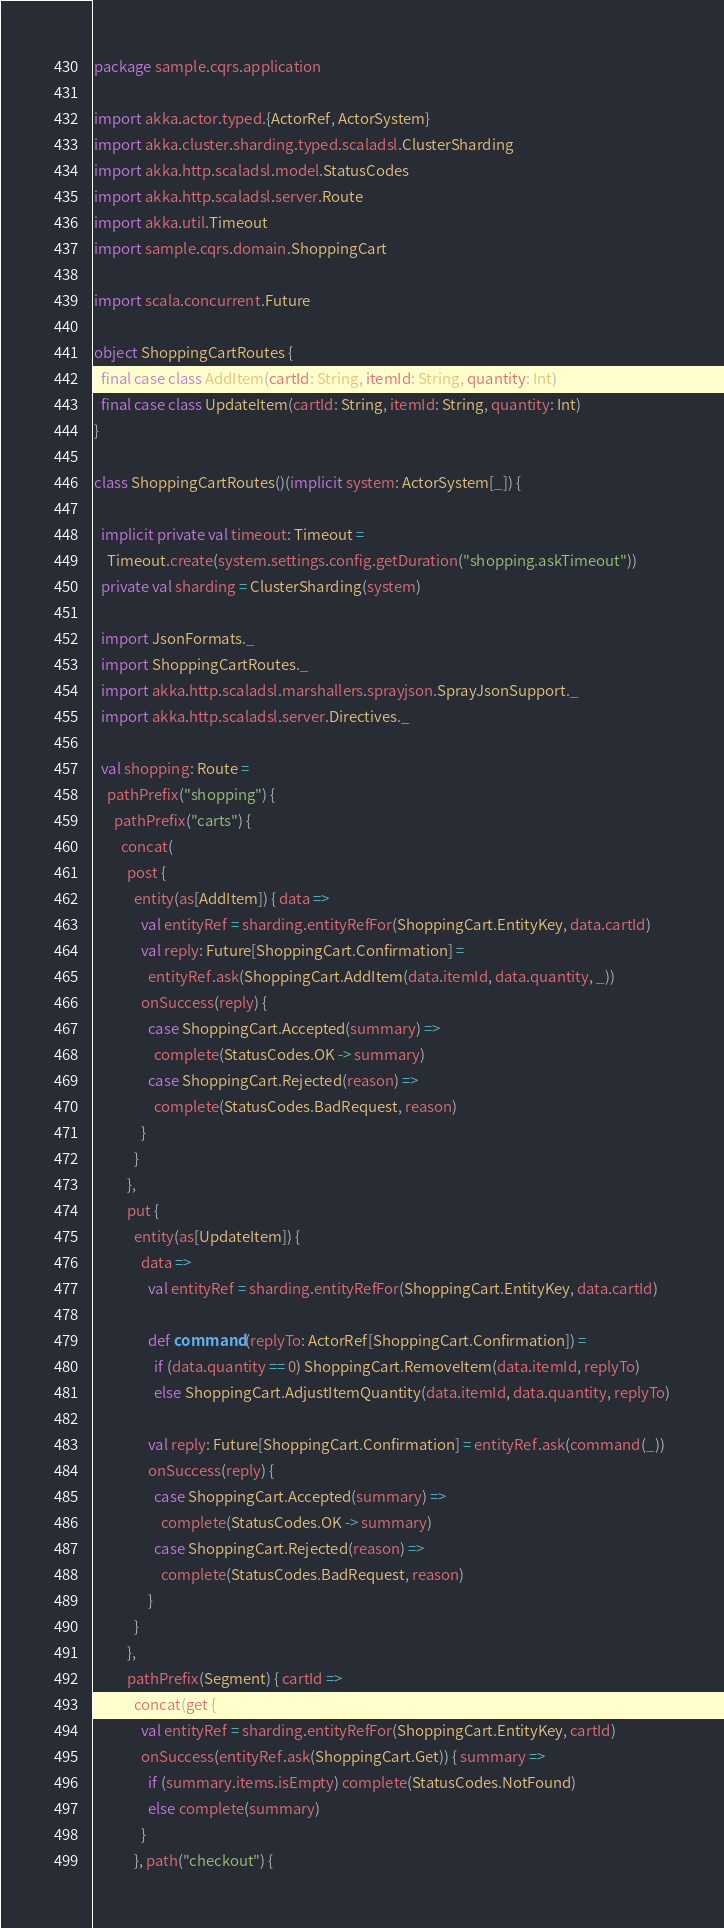<code> <loc_0><loc_0><loc_500><loc_500><_Scala_>package sample.cqrs.application

import akka.actor.typed.{ActorRef, ActorSystem}
import akka.cluster.sharding.typed.scaladsl.ClusterSharding
import akka.http.scaladsl.model.StatusCodes
import akka.http.scaladsl.server.Route
import akka.util.Timeout
import sample.cqrs.domain.ShoppingCart

import scala.concurrent.Future

object ShoppingCartRoutes {
  final case class AddItem(cartId: String, itemId: String, quantity: Int)
  final case class UpdateItem(cartId: String, itemId: String, quantity: Int)
}

class ShoppingCartRoutes()(implicit system: ActorSystem[_]) {

  implicit private val timeout: Timeout =
    Timeout.create(system.settings.config.getDuration("shopping.askTimeout"))
  private val sharding = ClusterSharding(system)

  import JsonFormats._
  import ShoppingCartRoutes._
  import akka.http.scaladsl.marshallers.sprayjson.SprayJsonSupport._
  import akka.http.scaladsl.server.Directives._

  val shopping: Route =
    pathPrefix("shopping") {
      pathPrefix("carts") {
        concat(
          post {
            entity(as[AddItem]) { data =>
              val entityRef = sharding.entityRefFor(ShoppingCart.EntityKey, data.cartId)
              val reply: Future[ShoppingCart.Confirmation] =
                entityRef.ask(ShoppingCart.AddItem(data.itemId, data.quantity, _))
              onSuccess(reply) {
                case ShoppingCart.Accepted(summary) =>
                  complete(StatusCodes.OK -> summary)
                case ShoppingCart.Rejected(reason) =>
                  complete(StatusCodes.BadRequest, reason)
              }
            }
          },
          put {
            entity(as[UpdateItem]) {
              data =>
                val entityRef = sharding.entityRefFor(ShoppingCart.EntityKey, data.cartId)

                def command(replyTo: ActorRef[ShoppingCart.Confirmation]) =
                  if (data.quantity == 0) ShoppingCart.RemoveItem(data.itemId, replyTo)
                  else ShoppingCart.AdjustItemQuantity(data.itemId, data.quantity, replyTo)

                val reply: Future[ShoppingCart.Confirmation] = entityRef.ask(command(_))
                onSuccess(reply) {
                  case ShoppingCart.Accepted(summary) =>
                    complete(StatusCodes.OK -> summary)
                  case ShoppingCart.Rejected(reason) =>
                    complete(StatusCodes.BadRequest, reason)
                }
            }
          },
          pathPrefix(Segment) { cartId =>
            concat(get {
              val entityRef = sharding.entityRefFor(ShoppingCart.EntityKey, cartId)
              onSuccess(entityRef.ask(ShoppingCart.Get)) { summary =>
                if (summary.items.isEmpty) complete(StatusCodes.NotFound)
                else complete(summary)
              }
            }, path("checkout") {</code> 